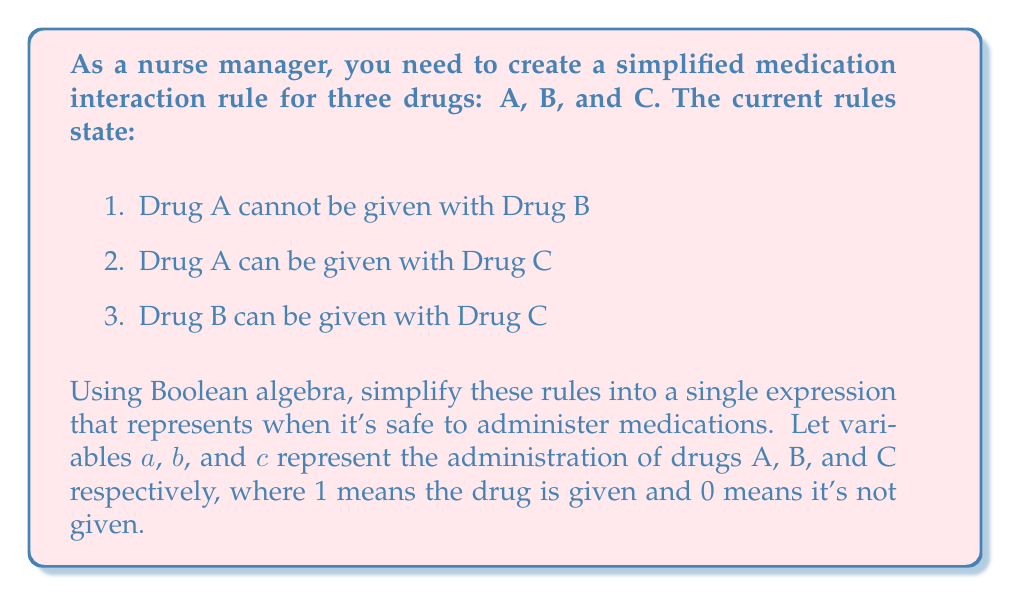Give your solution to this math problem. Let's approach this step-by-step using Boolean algebra:

1. First, we need to translate each rule into a Boolean expression:
   - Rule 1: $a$ and $b$ cannot both be 1, so we can express this as $\overline{ab}$
   - Rule 2: $a$ and $c$ can be given together, so no restriction is needed
   - Rule 3: $b$ and $c$ can be given together, so no restriction is needed

2. The overall safe administration condition is the combination of these rules:
   $$ \text{Safe} = \overline{ab} $$

3. To expand this expression, we can use one of De Morgan's laws:
   $$ \overline{ab} = \overline{a} + \overline{b} $$

4. This means that it's safe to administer medications when either Drug A is not given OR Drug B is not given (or both are not given).

5. We can further clarify this by considering all possible combinations:
   - $\overline{a}\overline{b}\overline{c}$: No drugs given (safe)
   - $\overline{a}\overline{b}c$: Only C given (safe)
   - $\overline{a}b\overline{c}$: Only B given (safe)
   - $\overline{a}bc$: B and C given (safe)
   - $a\overline{b}\overline{c}$: Only A given (safe)
   - $a\overline{b}c$: A and C given (safe)

6. The unsafe combination is $abc$ (all drugs given together), which is correctly excluded by our simplified rule.
Answer: $\text{Safe} = \overline{a} + \overline{b}$ 